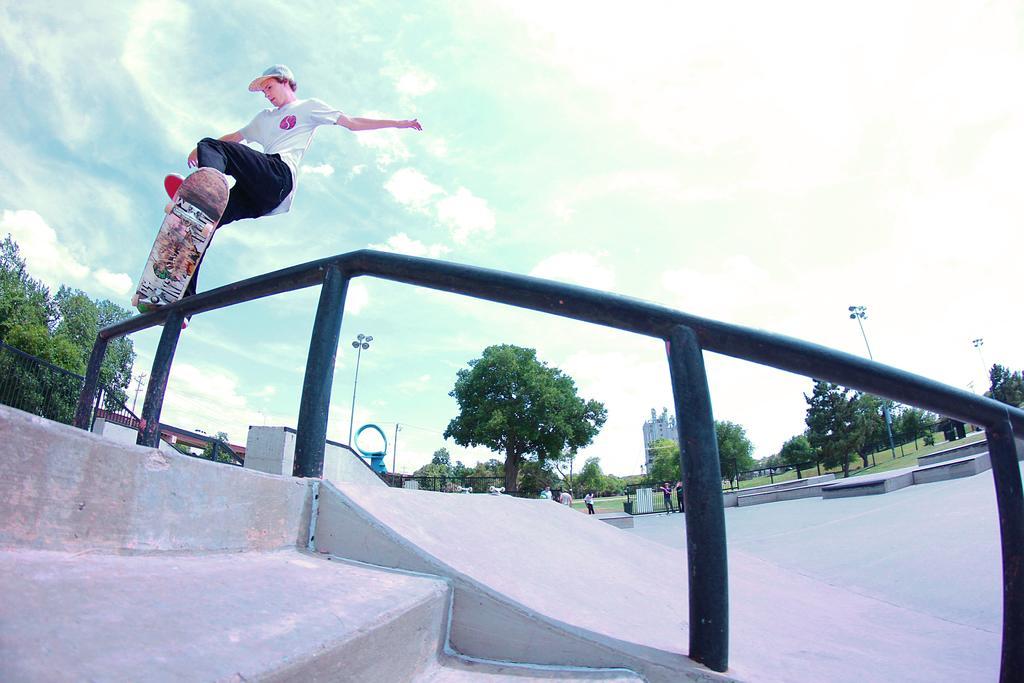Describe this image in one or two sentences. In this image we can see a person, iron rods and a ramp. In the background of the image there are some trees, persons, buildings, poles and some other objects. At the bottom of the image there are some steps. At the top of the image there is the sky. 